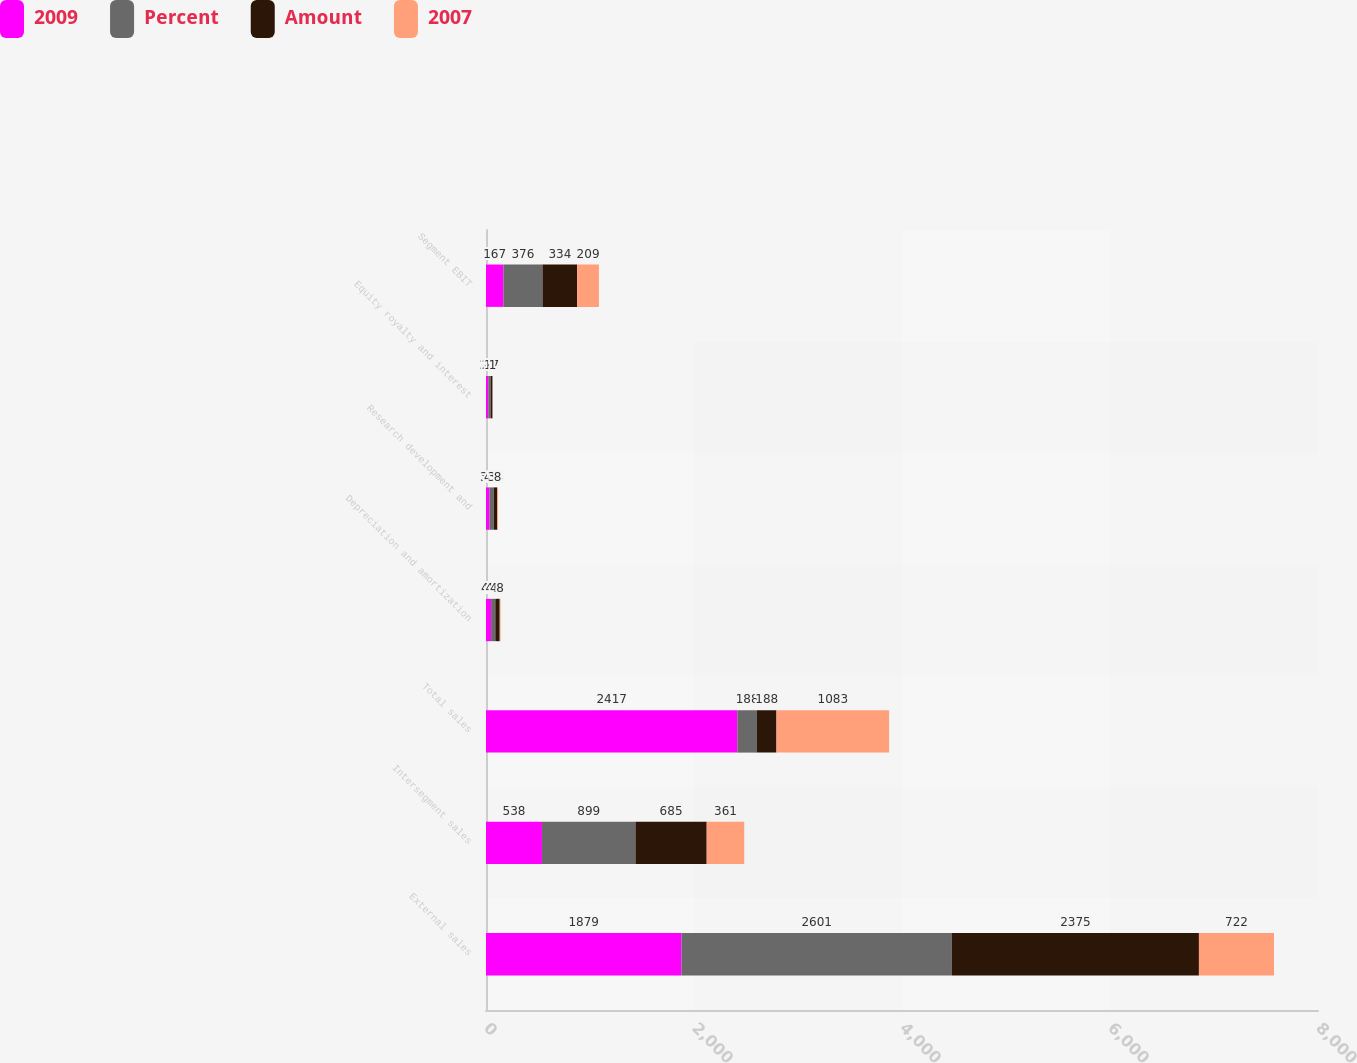Convert chart. <chart><loc_0><loc_0><loc_500><loc_500><stacked_bar_chart><ecel><fcel>External sales<fcel>Intersegment sales<fcel>Total sales<fcel>Depreciation and amortization<fcel>Research development and<fcel>Equity royalty and interest<fcel>Segment EBIT<nl><fcel>2009<fcel>1879<fcel>538<fcel>2417<fcel>49<fcel>33<fcel>22<fcel>167<nl><fcel>Percent<fcel>2601<fcel>899<fcel>188<fcel>41<fcel>41<fcel>23<fcel>376<nl><fcel>Amount<fcel>2375<fcel>685<fcel>188<fcel>42<fcel>34<fcel>17<fcel>334<nl><fcel>2007<fcel>722<fcel>361<fcel>1083<fcel>8<fcel>8<fcel>1<fcel>209<nl></chart> 